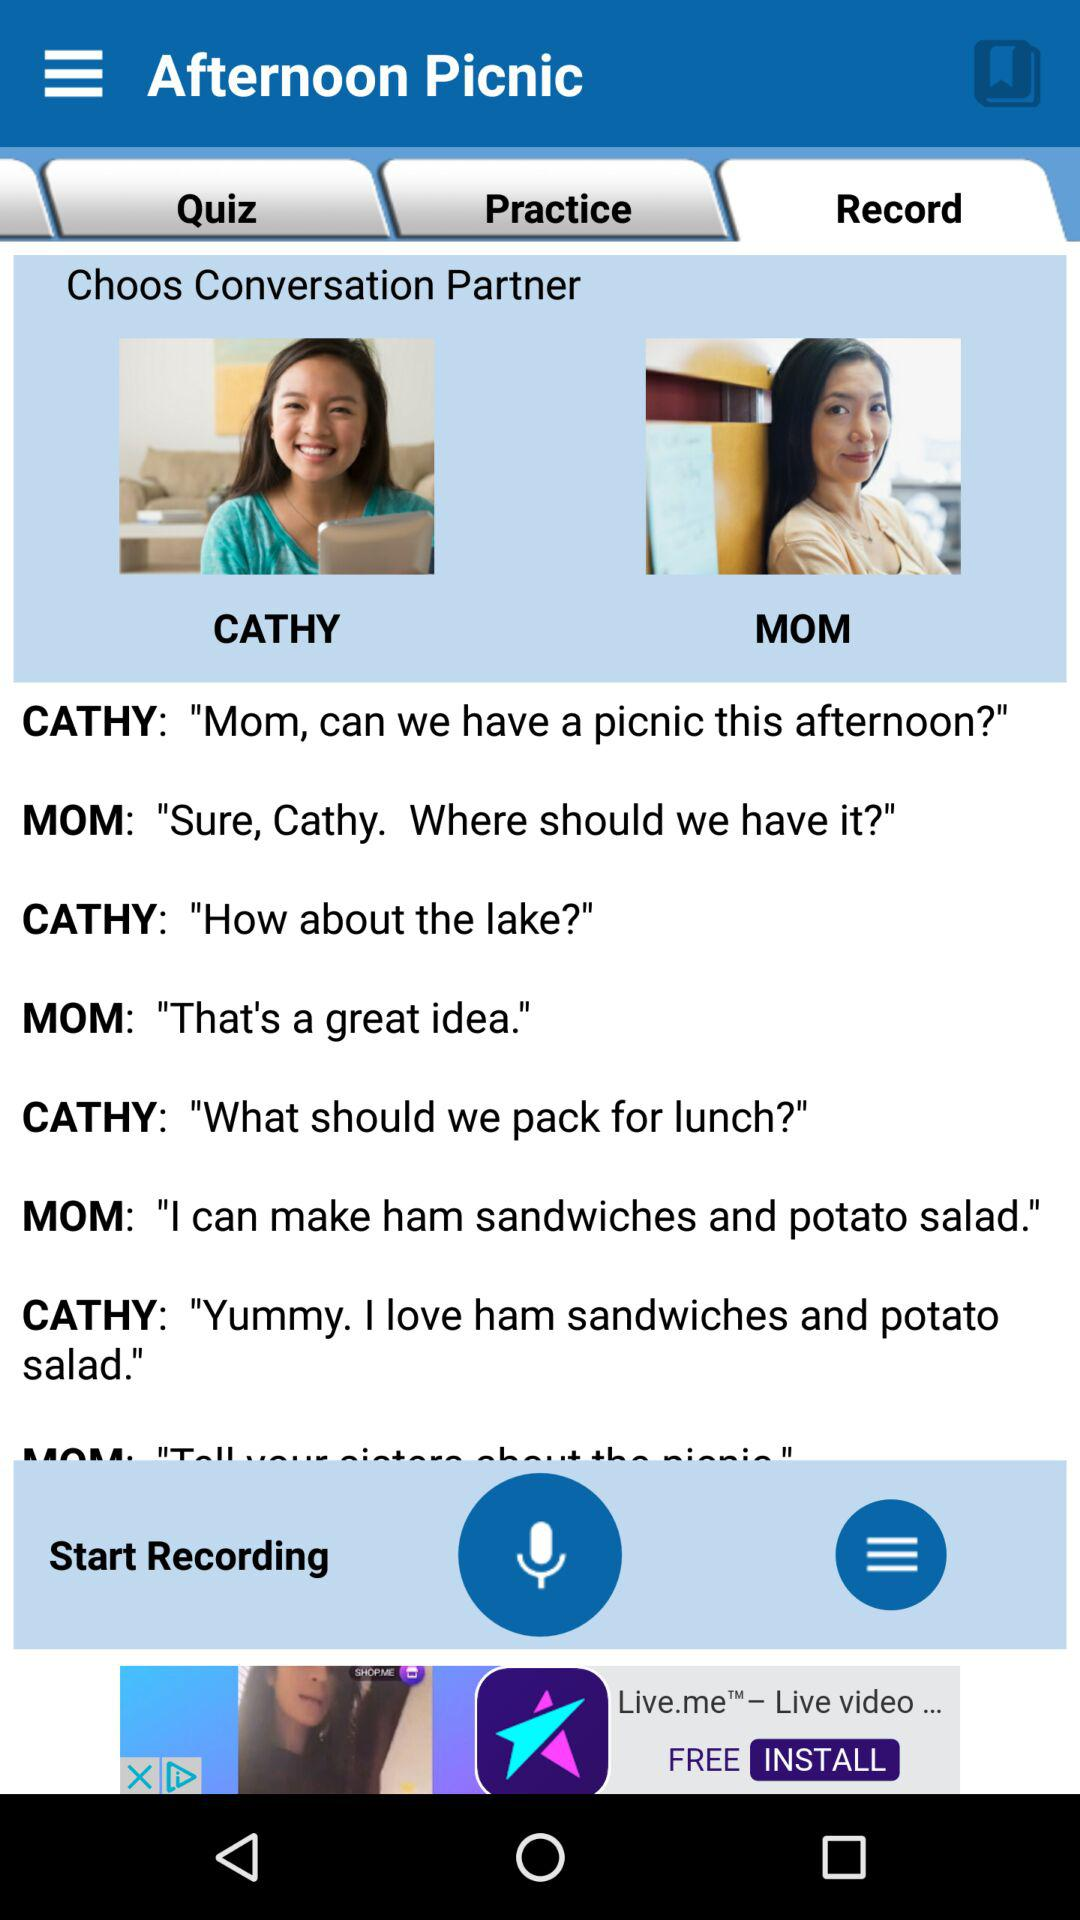What is the application name? The application name is "Afternoon Picnic". 